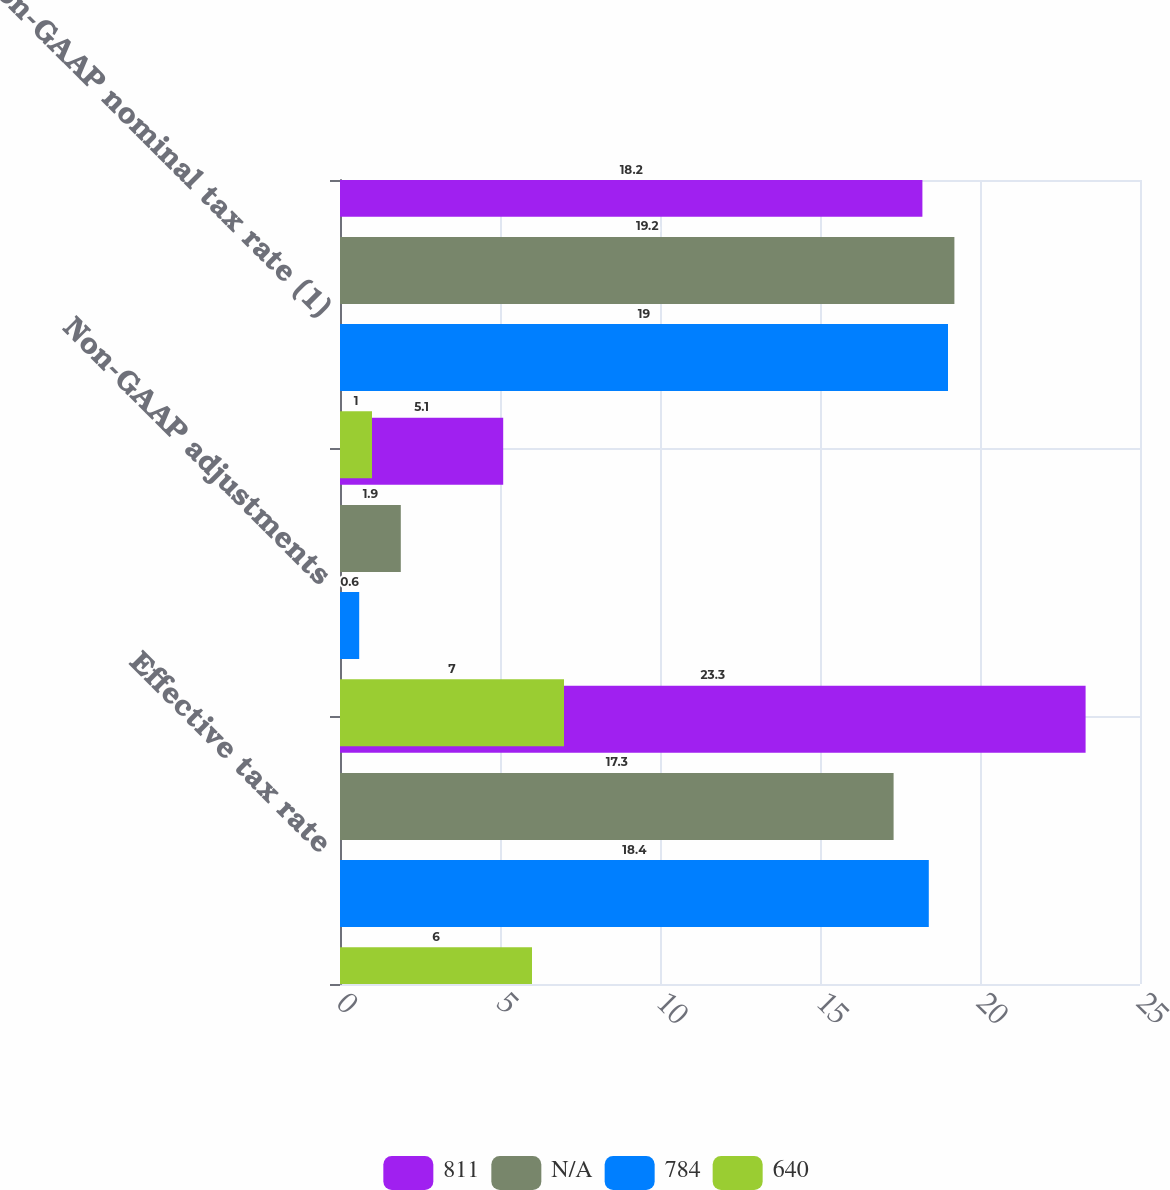Convert chart to OTSL. <chart><loc_0><loc_0><loc_500><loc_500><stacked_bar_chart><ecel><fcel>Effective tax rate<fcel>Non-GAAP adjustments<fcel>Non-GAAP nominal tax rate (1)<nl><fcel>811<fcel>23.3<fcel>5.1<fcel>18.2<nl><fcel>nan<fcel>17.3<fcel>1.9<fcel>19.2<nl><fcel>784<fcel>18.4<fcel>0.6<fcel>19<nl><fcel>640<fcel>6<fcel>7<fcel>1<nl></chart> 